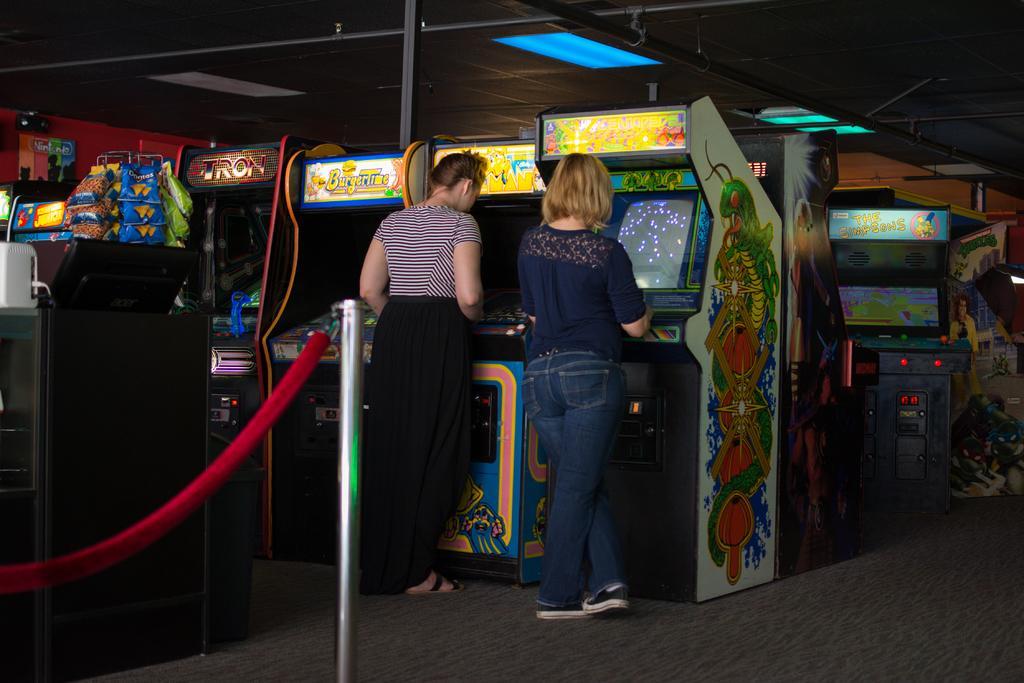Please provide a concise description of this image. There are two persons standing in the middle of this image and there are some arcade machines in the background. There is a floor at the bottom of this image. 